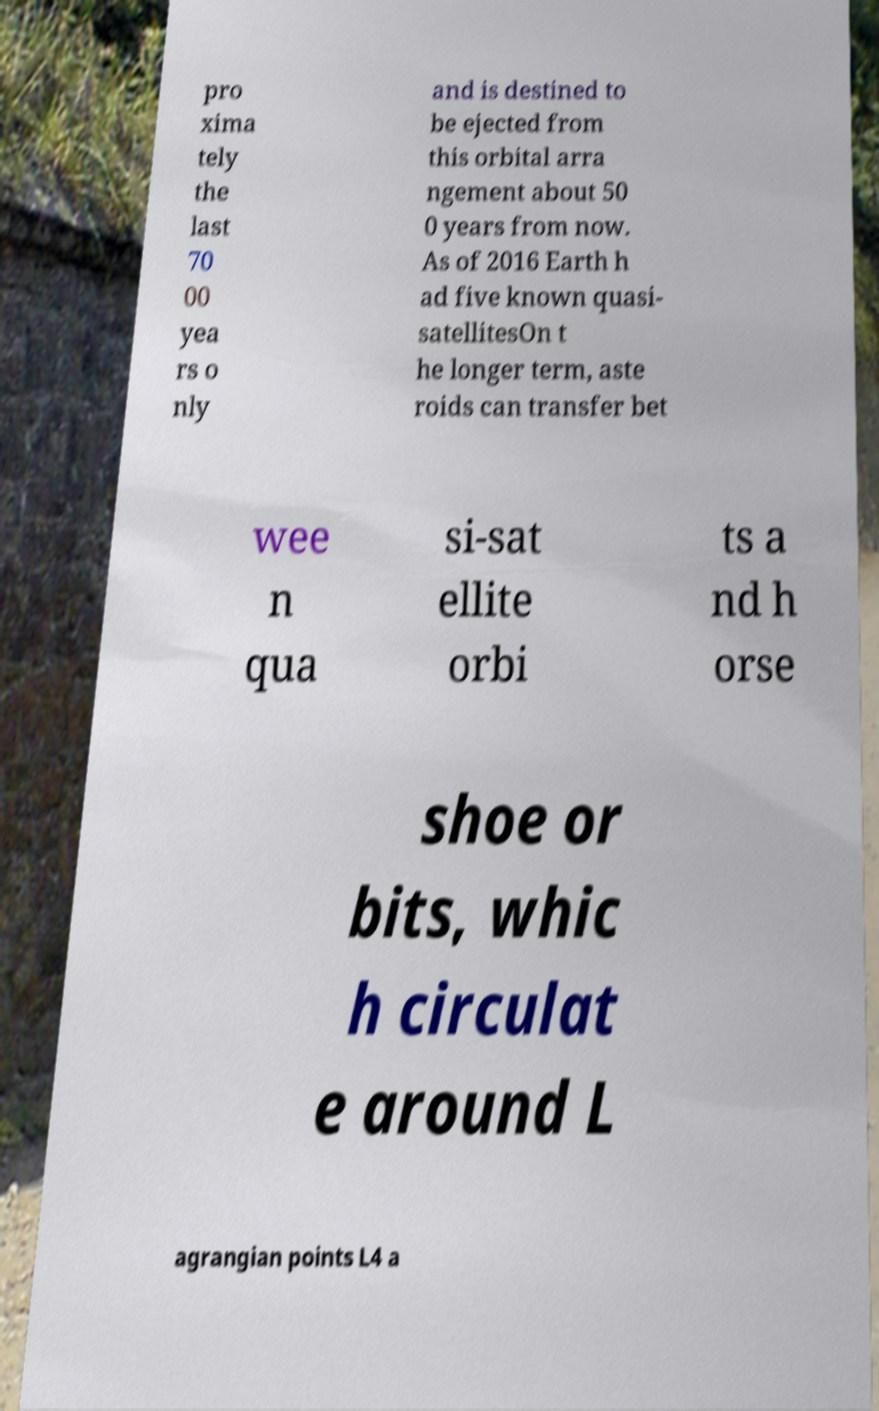For documentation purposes, I need the text within this image transcribed. Could you provide that? pro xima tely the last 70 00 yea rs o nly and is destined to be ejected from this orbital arra ngement about 50 0 years from now. As of 2016 Earth h ad five known quasi- satellitesOn t he longer term, aste roids can transfer bet wee n qua si-sat ellite orbi ts a nd h orse shoe or bits, whic h circulat e around L agrangian points L4 a 